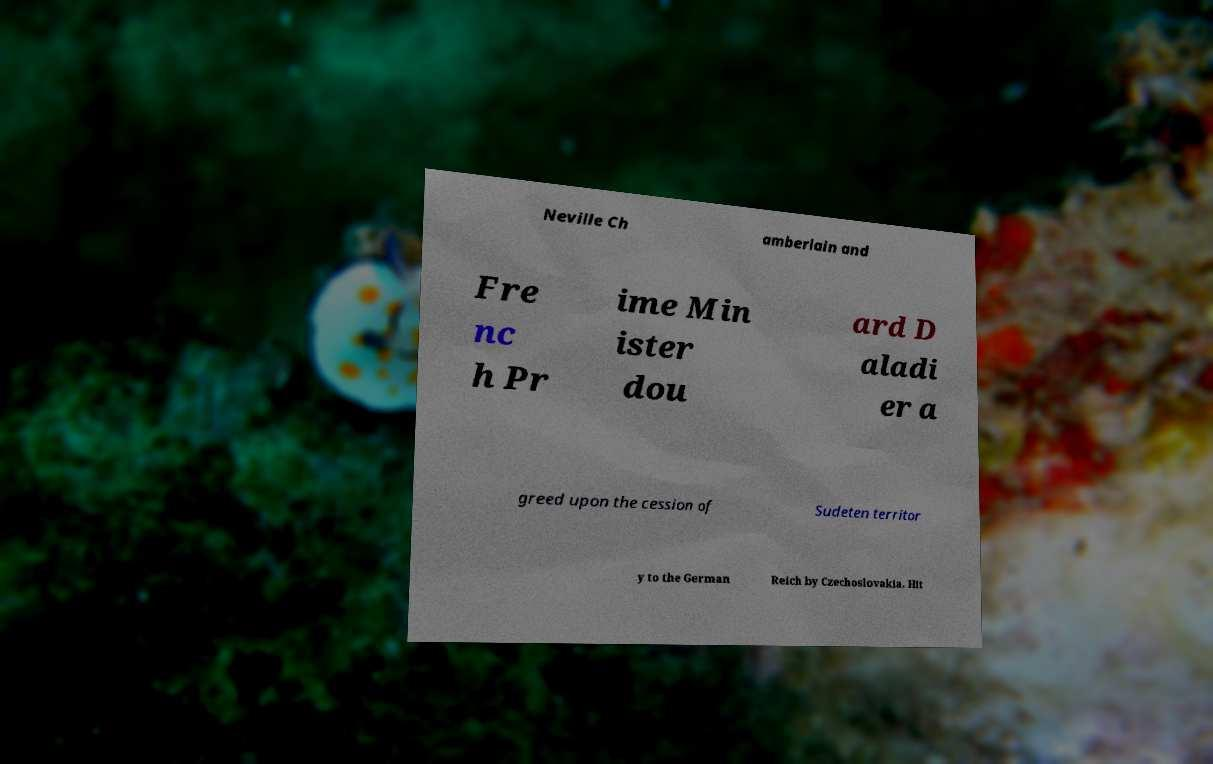There's text embedded in this image that I need extracted. Can you transcribe it verbatim? Neville Ch amberlain and Fre nc h Pr ime Min ister dou ard D aladi er a greed upon the cession of Sudeten territor y to the German Reich by Czechoslovakia. Hit 